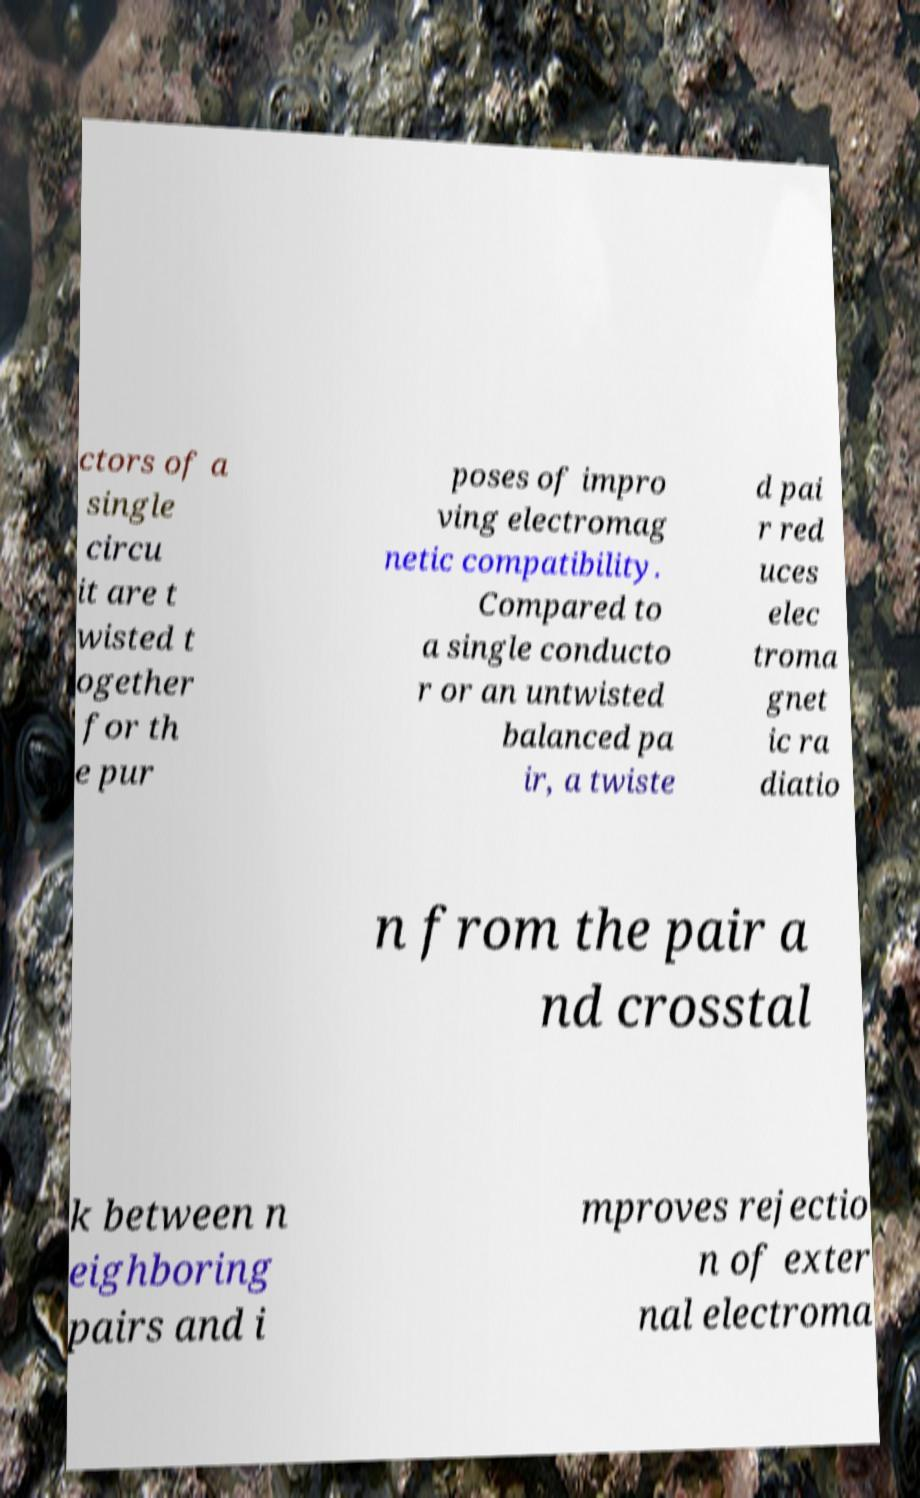I need the written content from this picture converted into text. Can you do that? ctors of a single circu it are t wisted t ogether for th e pur poses of impro ving electromag netic compatibility. Compared to a single conducto r or an untwisted balanced pa ir, a twiste d pai r red uces elec troma gnet ic ra diatio n from the pair a nd crosstal k between n eighboring pairs and i mproves rejectio n of exter nal electroma 